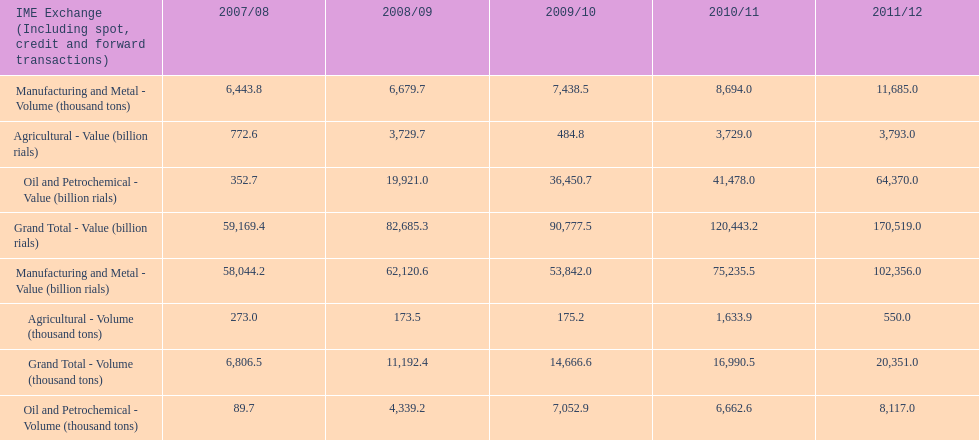How many consecutive year did the grand total value grow in iran? 4. 